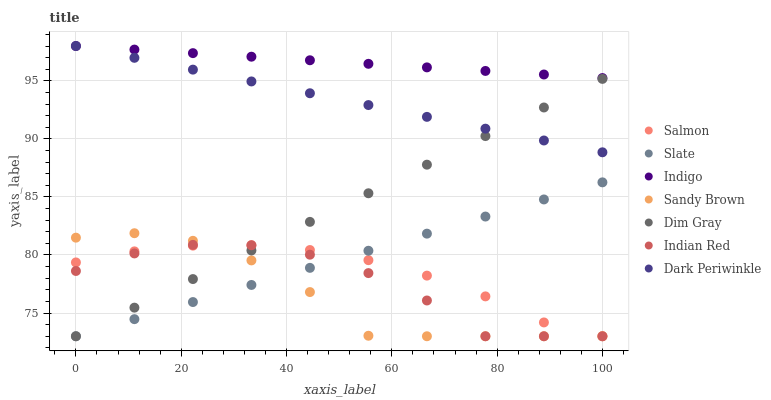Does Sandy Brown have the minimum area under the curve?
Answer yes or no. Yes. Does Indigo have the maximum area under the curve?
Answer yes or no. Yes. Does Slate have the minimum area under the curve?
Answer yes or no. No. Does Slate have the maximum area under the curve?
Answer yes or no. No. Is Indigo the smoothest?
Answer yes or no. Yes. Is Sandy Brown the roughest?
Answer yes or no. Yes. Is Slate the smoothest?
Answer yes or no. No. Is Slate the roughest?
Answer yes or no. No. Does Dim Gray have the lowest value?
Answer yes or no. Yes. Does Indigo have the lowest value?
Answer yes or no. No. Does Dark Periwinkle have the highest value?
Answer yes or no. Yes. Does Slate have the highest value?
Answer yes or no. No. Is Salmon less than Indigo?
Answer yes or no. Yes. Is Indigo greater than Sandy Brown?
Answer yes or no. Yes. Does Slate intersect Indian Red?
Answer yes or no. Yes. Is Slate less than Indian Red?
Answer yes or no. No. Is Slate greater than Indian Red?
Answer yes or no. No. Does Salmon intersect Indigo?
Answer yes or no. No. 